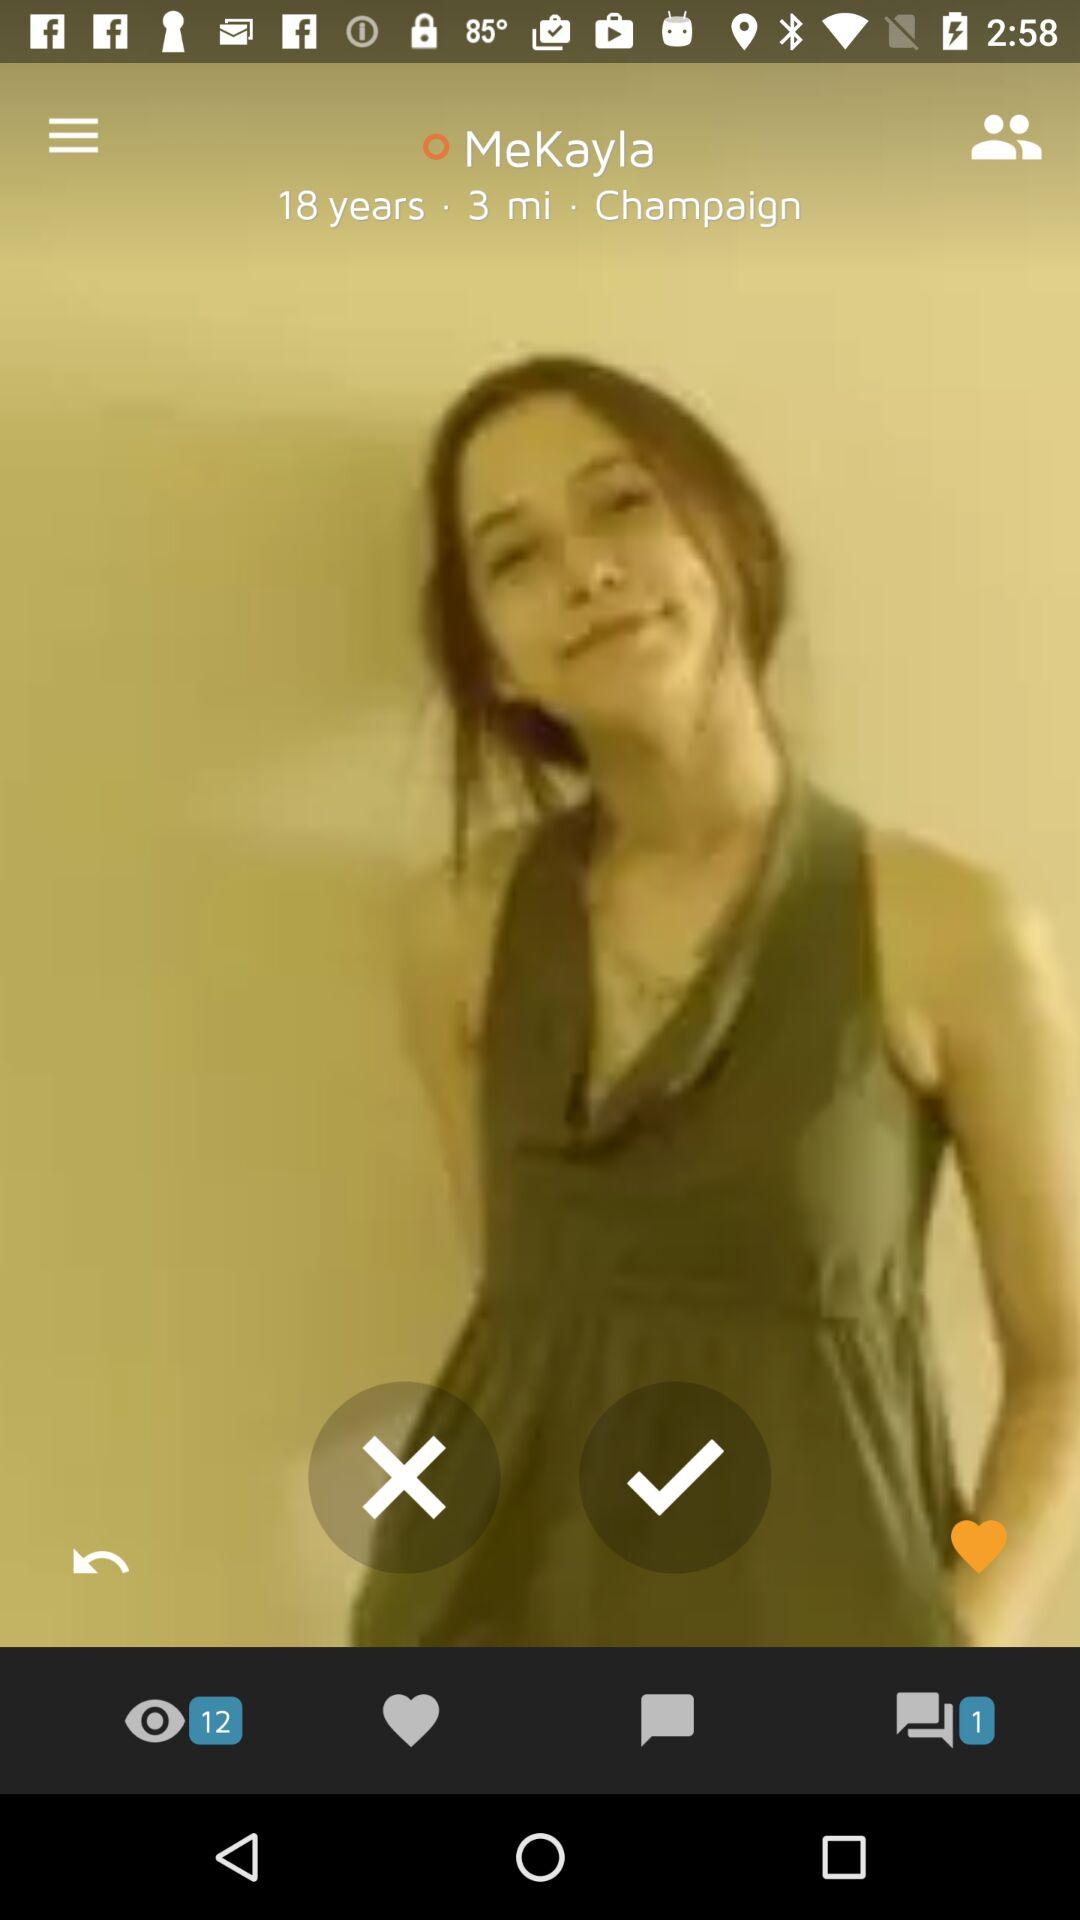How many people's views are there? There are 12 people's views. 